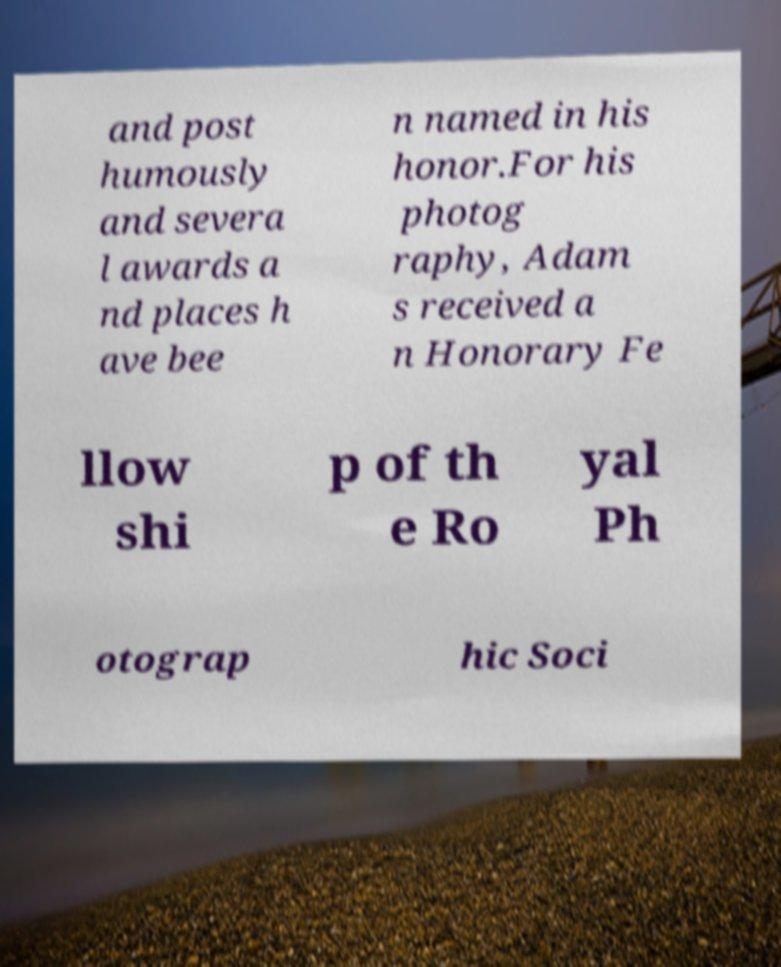Please read and relay the text visible in this image. What does it say? and post humously and severa l awards a nd places h ave bee n named in his honor.For his photog raphy, Adam s received a n Honorary Fe llow shi p of th e Ro yal Ph otograp hic Soci 